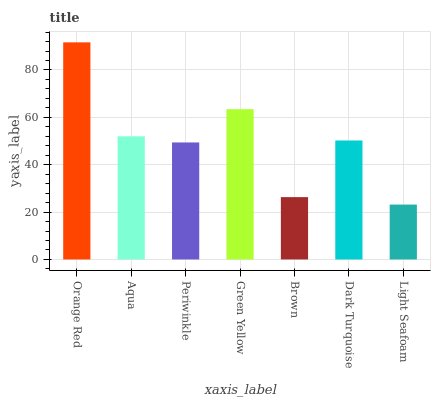Is Aqua the minimum?
Answer yes or no. No. Is Aqua the maximum?
Answer yes or no. No. Is Orange Red greater than Aqua?
Answer yes or no. Yes. Is Aqua less than Orange Red?
Answer yes or no. Yes. Is Aqua greater than Orange Red?
Answer yes or no. No. Is Orange Red less than Aqua?
Answer yes or no. No. Is Dark Turquoise the high median?
Answer yes or no. Yes. Is Dark Turquoise the low median?
Answer yes or no. Yes. Is Brown the high median?
Answer yes or no. No. Is Periwinkle the low median?
Answer yes or no. No. 